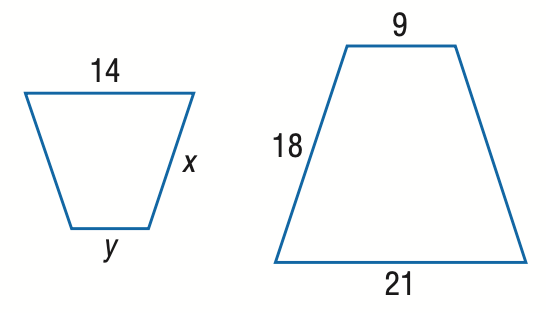Answer the mathemtical geometry problem and directly provide the correct option letter.
Question: Find y.
Choices: A: 6 B: 7 C: 9 D: 12 A 